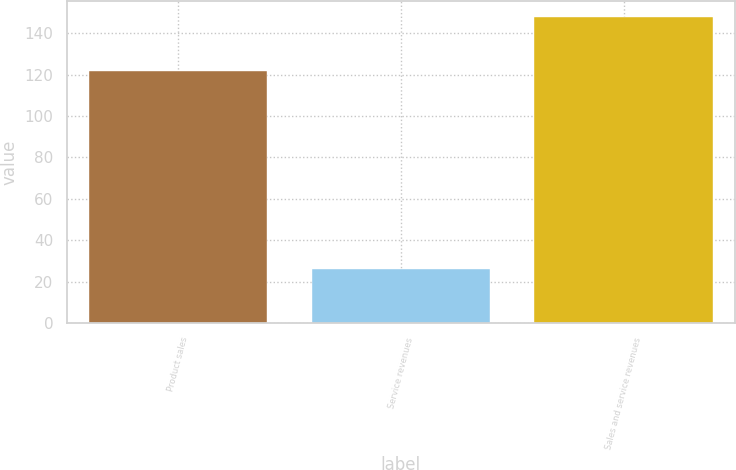<chart> <loc_0><loc_0><loc_500><loc_500><bar_chart><fcel>Product sales<fcel>Service revenues<fcel>Sales and service revenues<nl><fcel>122<fcel>26<fcel>148<nl></chart> 